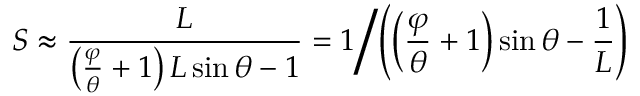<formula> <loc_0><loc_0><loc_500><loc_500>S \approx { \frac { L } { \left ( { \frac { \varphi } { \theta } } + 1 \right ) L \sin \theta - 1 } } = 1 \left / \left ( \left ( { \frac { \varphi } { \theta } } + 1 \right ) \sin \theta - { \frac { 1 } { L } } \right )</formula> 